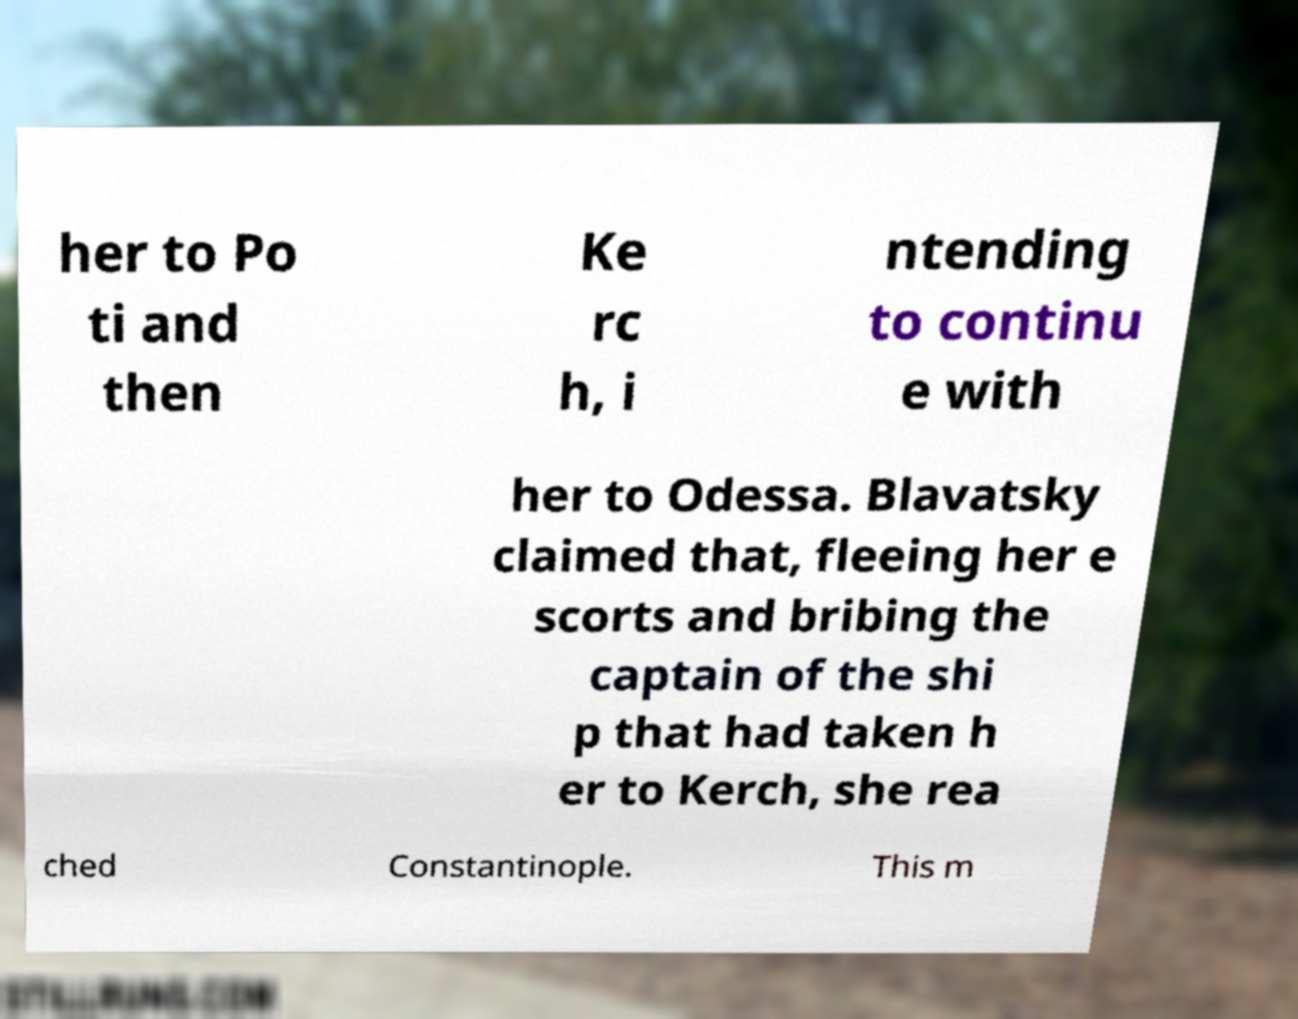Could you extract and type out the text from this image? her to Po ti and then Ke rc h, i ntending to continu e with her to Odessa. Blavatsky claimed that, fleeing her e scorts and bribing the captain of the shi p that had taken h er to Kerch, she rea ched Constantinople. This m 